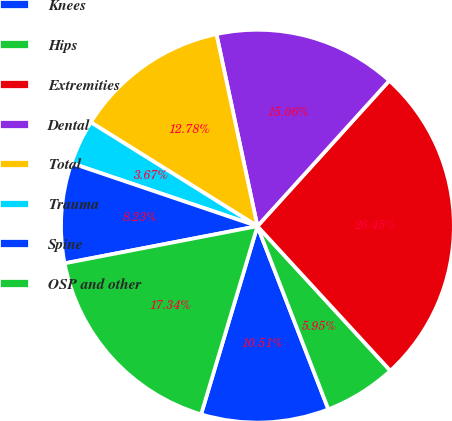Convert chart to OTSL. <chart><loc_0><loc_0><loc_500><loc_500><pie_chart><fcel>Knees<fcel>Hips<fcel>Extremities<fcel>Dental<fcel>Total<fcel>Trauma<fcel>Spine<fcel>OSP and other<nl><fcel>10.51%<fcel>5.95%<fcel>26.45%<fcel>15.06%<fcel>12.78%<fcel>3.67%<fcel>8.23%<fcel>17.34%<nl></chart> 